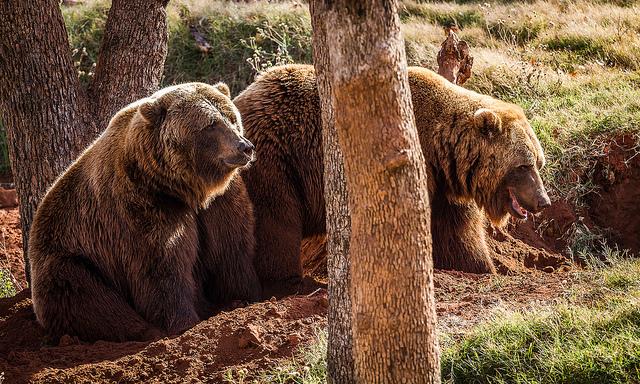Are all the bears the same color?
Be succinct. Yes. Is one of the bears sitting on a rock?
Write a very short answer. No. Was the name of an American president used to name a toy version of this animal?
Concise answer only. Teddy roosevelt. Are the bears in water?
Write a very short answer. No. Are the bears the same color?
Write a very short answer. Yes. Is the bear alone?
Short answer required. No. How many bears are there?
Write a very short answer. 2. How many animals are in this image?
Be succinct. 2. What animal is in the picture?
Give a very brief answer. Bear. 